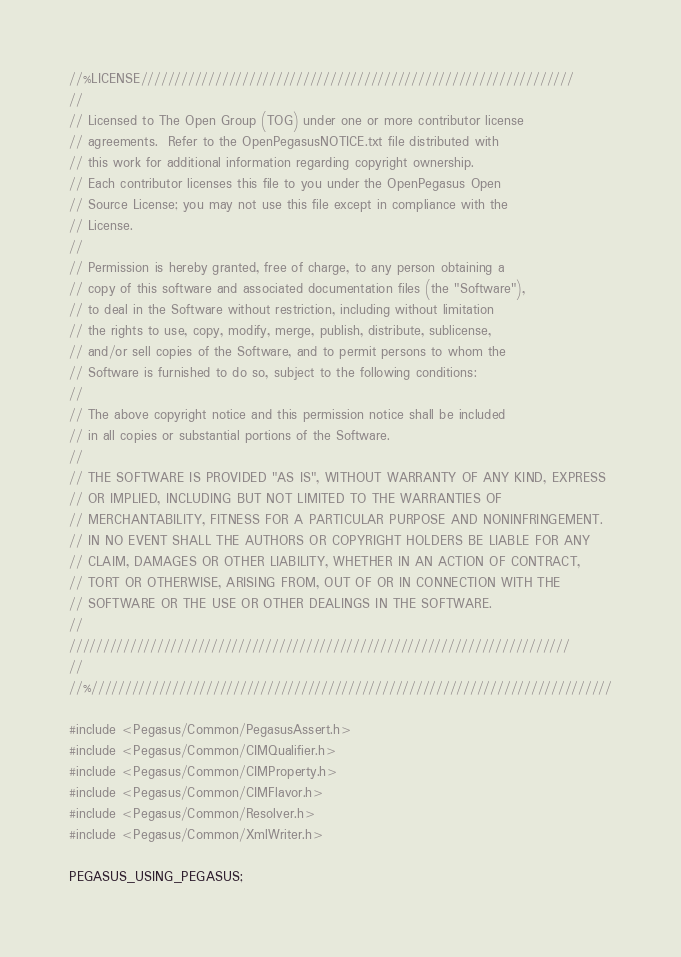Convert code to text. <code><loc_0><loc_0><loc_500><loc_500><_C++_>//%LICENSE////////////////////////////////////////////////////////////////
//
// Licensed to The Open Group (TOG) under one or more contributor license
// agreements.  Refer to the OpenPegasusNOTICE.txt file distributed with
// this work for additional information regarding copyright ownership.
// Each contributor licenses this file to you under the OpenPegasus Open
// Source License; you may not use this file except in compliance with the
// License.
//
// Permission is hereby granted, free of charge, to any person obtaining a
// copy of this software and associated documentation files (the "Software"),
// to deal in the Software without restriction, including without limitation
// the rights to use, copy, modify, merge, publish, distribute, sublicense,
// and/or sell copies of the Software, and to permit persons to whom the
// Software is furnished to do so, subject to the following conditions:
//
// The above copyright notice and this permission notice shall be included
// in all copies or substantial portions of the Software.
//
// THE SOFTWARE IS PROVIDED "AS IS", WITHOUT WARRANTY OF ANY KIND, EXPRESS
// OR IMPLIED, INCLUDING BUT NOT LIMITED TO THE WARRANTIES OF
// MERCHANTABILITY, FITNESS FOR A PARTICULAR PURPOSE AND NONINFRINGEMENT.
// IN NO EVENT SHALL THE AUTHORS OR COPYRIGHT HOLDERS BE LIABLE FOR ANY
// CLAIM, DAMAGES OR OTHER LIABILITY, WHETHER IN AN ACTION OF CONTRACT,
// TORT OR OTHERWISE, ARISING FROM, OUT OF OR IN CONNECTION WITH THE
// SOFTWARE OR THE USE OR OTHER DEALINGS IN THE SOFTWARE.
//
//////////////////////////////////////////////////////////////////////////
//
//%/////////////////////////////////////////////////////////////////////////////

#include <Pegasus/Common/PegasusAssert.h>
#include <Pegasus/Common/CIMQualifier.h>
#include <Pegasus/Common/CIMProperty.h>
#include <Pegasus/Common/CIMFlavor.h>
#include <Pegasus/Common/Resolver.h>
#include <Pegasus/Common/XmlWriter.h>

PEGASUS_USING_PEGASUS;</code> 